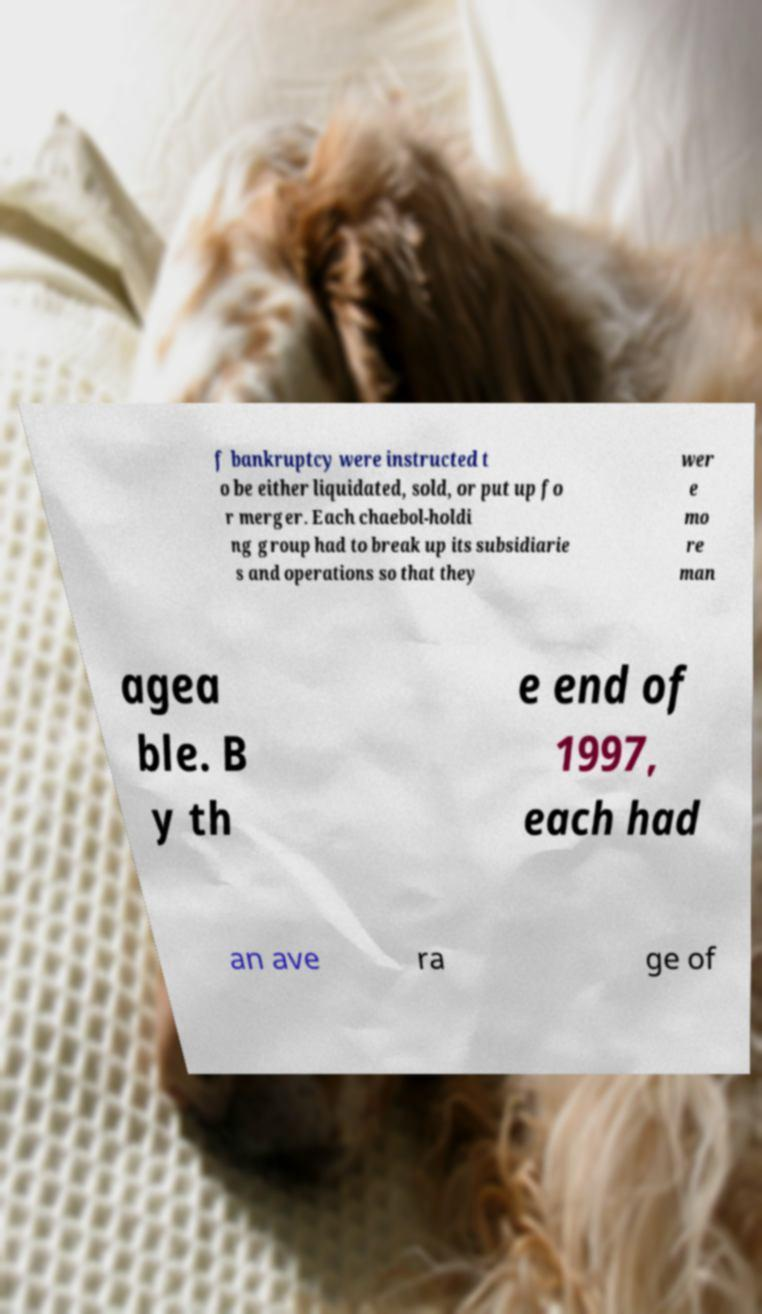For documentation purposes, I need the text within this image transcribed. Could you provide that? f bankruptcy were instructed t o be either liquidated, sold, or put up fo r merger. Each chaebol-holdi ng group had to break up its subsidiarie s and operations so that they wer e mo re man agea ble. B y th e end of 1997, each had an ave ra ge of 